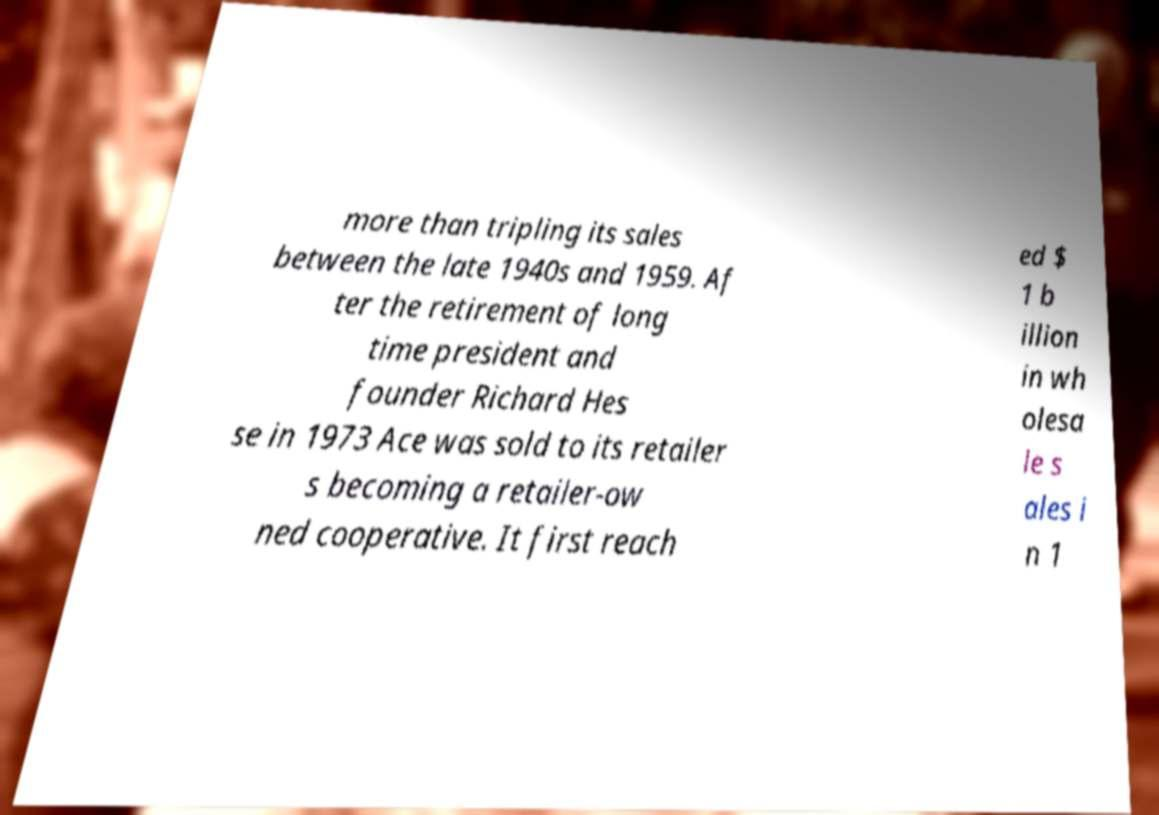For documentation purposes, I need the text within this image transcribed. Could you provide that? more than tripling its sales between the late 1940s and 1959. Af ter the retirement of long time president and founder Richard Hes se in 1973 Ace was sold to its retailer s becoming a retailer-ow ned cooperative. It first reach ed $ 1 b illion in wh olesa le s ales i n 1 